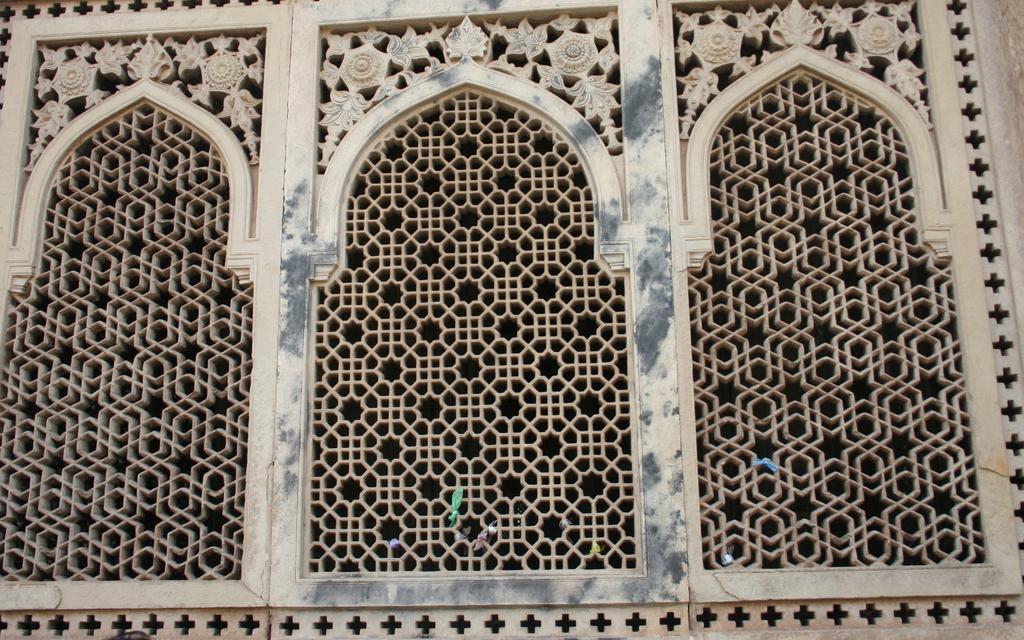In one or two sentences, can you explain what this image depicts? In the image there are three arches and they are of different designs. 